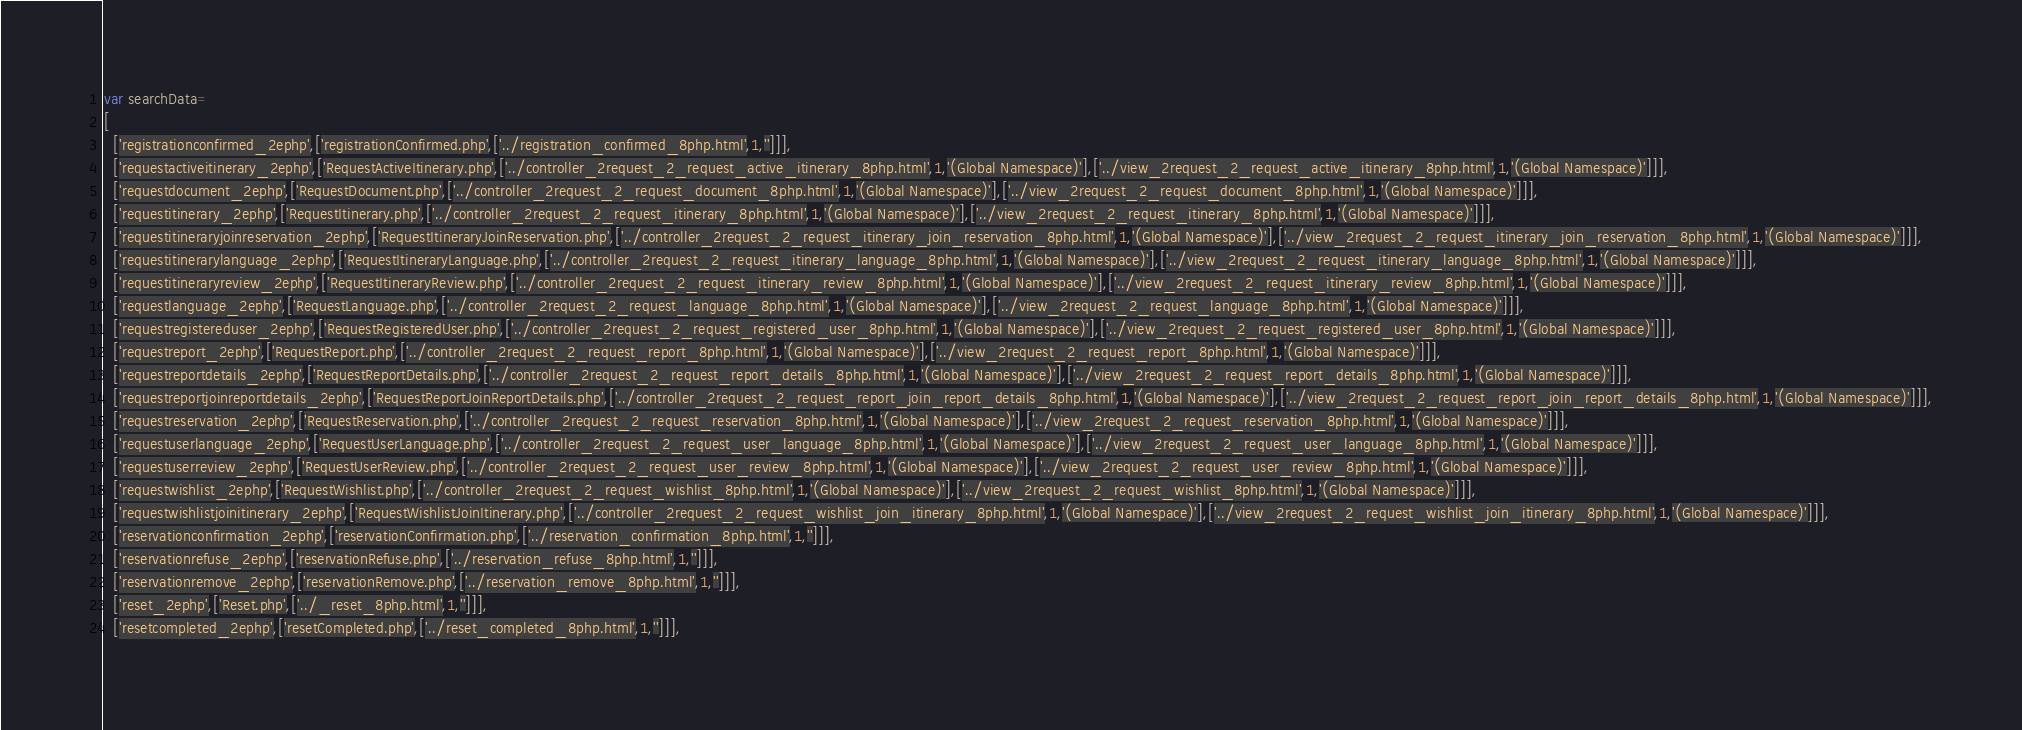<code> <loc_0><loc_0><loc_500><loc_500><_JavaScript_>var searchData=
[
  ['registrationconfirmed_2ephp',['registrationConfirmed.php',['../registration_confirmed_8php.html',1,'']]],
  ['requestactiveitinerary_2ephp',['RequestActiveItinerary.php',['../controller_2request_2_request_active_itinerary_8php.html',1,'(Global Namespace)'],['../view_2request_2_request_active_itinerary_8php.html',1,'(Global Namespace)']]],
  ['requestdocument_2ephp',['RequestDocument.php',['../controller_2request_2_request_document_8php.html',1,'(Global Namespace)'],['../view_2request_2_request_document_8php.html',1,'(Global Namespace)']]],
  ['requestitinerary_2ephp',['RequestItinerary.php',['../controller_2request_2_request_itinerary_8php.html',1,'(Global Namespace)'],['../view_2request_2_request_itinerary_8php.html',1,'(Global Namespace)']]],
  ['requestitineraryjoinreservation_2ephp',['RequestItineraryJoinReservation.php',['../controller_2request_2_request_itinerary_join_reservation_8php.html',1,'(Global Namespace)'],['../view_2request_2_request_itinerary_join_reservation_8php.html',1,'(Global Namespace)']]],
  ['requestitinerarylanguage_2ephp',['RequestItineraryLanguage.php',['../controller_2request_2_request_itinerary_language_8php.html',1,'(Global Namespace)'],['../view_2request_2_request_itinerary_language_8php.html',1,'(Global Namespace)']]],
  ['requestitineraryreview_2ephp',['RequestItineraryReview.php',['../controller_2request_2_request_itinerary_review_8php.html',1,'(Global Namespace)'],['../view_2request_2_request_itinerary_review_8php.html',1,'(Global Namespace)']]],
  ['requestlanguage_2ephp',['RequestLanguage.php',['../controller_2request_2_request_language_8php.html',1,'(Global Namespace)'],['../view_2request_2_request_language_8php.html',1,'(Global Namespace)']]],
  ['requestregistereduser_2ephp',['RequestRegisteredUser.php',['../controller_2request_2_request_registered_user_8php.html',1,'(Global Namespace)'],['../view_2request_2_request_registered_user_8php.html',1,'(Global Namespace)']]],
  ['requestreport_2ephp',['RequestReport.php',['../controller_2request_2_request_report_8php.html',1,'(Global Namespace)'],['../view_2request_2_request_report_8php.html',1,'(Global Namespace)']]],
  ['requestreportdetails_2ephp',['RequestReportDetails.php',['../controller_2request_2_request_report_details_8php.html',1,'(Global Namespace)'],['../view_2request_2_request_report_details_8php.html',1,'(Global Namespace)']]],
  ['requestreportjoinreportdetails_2ephp',['RequestReportJoinReportDetails.php',['../controller_2request_2_request_report_join_report_details_8php.html',1,'(Global Namespace)'],['../view_2request_2_request_report_join_report_details_8php.html',1,'(Global Namespace)']]],
  ['requestreservation_2ephp',['RequestReservation.php',['../controller_2request_2_request_reservation_8php.html',1,'(Global Namespace)'],['../view_2request_2_request_reservation_8php.html',1,'(Global Namespace)']]],
  ['requestuserlanguage_2ephp',['RequestUserLanguage.php',['../controller_2request_2_request_user_language_8php.html',1,'(Global Namespace)'],['../view_2request_2_request_user_language_8php.html',1,'(Global Namespace)']]],
  ['requestuserreview_2ephp',['RequestUserReview.php',['../controller_2request_2_request_user_review_8php.html',1,'(Global Namespace)'],['../view_2request_2_request_user_review_8php.html',1,'(Global Namespace)']]],
  ['requestwishlist_2ephp',['RequestWishlist.php',['../controller_2request_2_request_wishlist_8php.html',1,'(Global Namespace)'],['../view_2request_2_request_wishlist_8php.html',1,'(Global Namespace)']]],
  ['requestwishlistjoinitinerary_2ephp',['RequestWishlistJoinItinerary.php',['../controller_2request_2_request_wishlist_join_itinerary_8php.html',1,'(Global Namespace)'],['../view_2request_2_request_wishlist_join_itinerary_8php.html',1,'(Global Namespace)']]],
  ['reservationconfirmation_2ephp',['reservationConfirmation.php',['../reservation_confirmation_8php.html',1,'']]],
  ['reservationrefuse_2ephp',['reservationRefuse.php',['../reservation_refuse_8php.html',1,'']]],
  ['reservationremove_2ephp',['reservationRemove.php',['../reservation_remove_8php.html',1,'']]],
  ['reset_2ephp',['Reset.php',['../_reset_8php.html',1,'']]],
  ['resetcompleted_2ephp',['resetCompleted.php',['../reset_completed_8php.html',1,'']]],</code> 